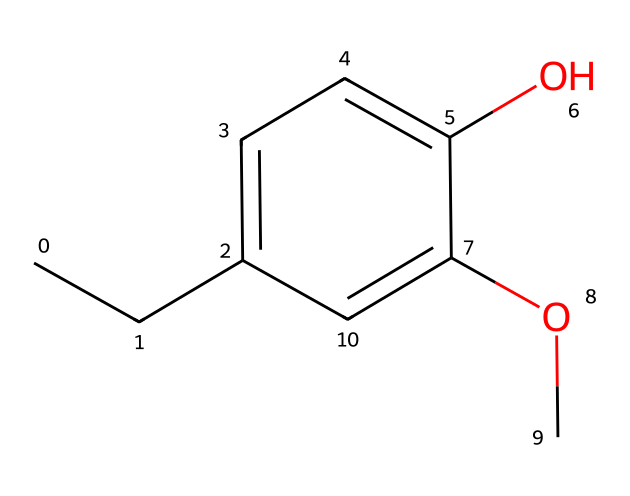What is the primary functional group in this compound? The structure shows a hydroxyl group (-OH) attached to the aromatic ring, which is characteristic of phenols. Therefore, the primary functional group present in this compound is the hydroxyl group.
Answer: hydroxyl group How many carbon atoms are in eugenol? By analyzing the SMILES representation, we can count the carbon atoms present in the structure. There are ten carbon atoms in total in the chemical structure of eugenol.
Answer: ten What type of compound is eugenol classified as? The presence of the aromatic ring and the hydroxyl group in the compound confirms that eugenol is classified as a phenolic compound, a special type of aromatic compound.
Answer: phenolic Which part of the chemical structure contributes to its pain-relieving properties? The hydroxyl group enhances the chemical's interaction with pain receptors in the body, contributing to its analgesic (pain-relieving) properties. This structural feature allows eugenol to exert its therapeutic effects.
Answer: hydroxyl group Is eugenol a simple or complex phenol? Eugenol, with its specific structural features including a methoxy group (-OCH3) and a hydroxyl group (-OH) on the aromatic ring, is considered a simple phenol due to its relatively straightforward arrangement compared to more complex phenolic structures.
Answer: simple What is the total number of oxygen atoms in this compound? Reviewing the SMILES representation, there are two oxygen atoms present in eugenol's structure, one in the hydroxyl group and one in the methoxy group, indicating that eugenol has a total of two oxygen atoms.
Answer: two 